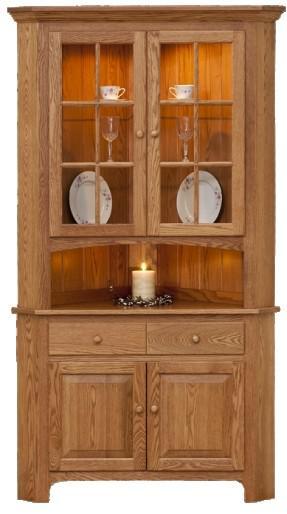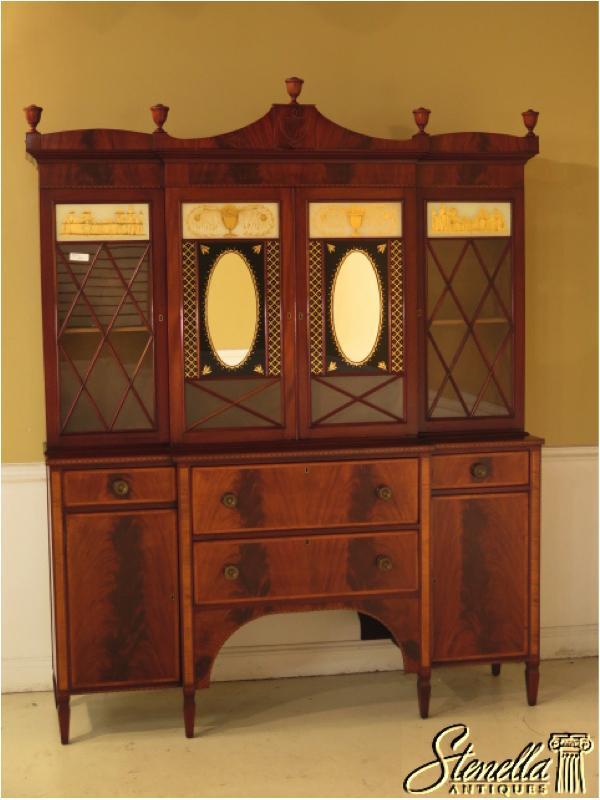The first image is the image on the left, the second image is the image on the right. For the images shown, is this caption "There are four drawers on the cabinet in the image on the left." true? Answer yes or no. No. 